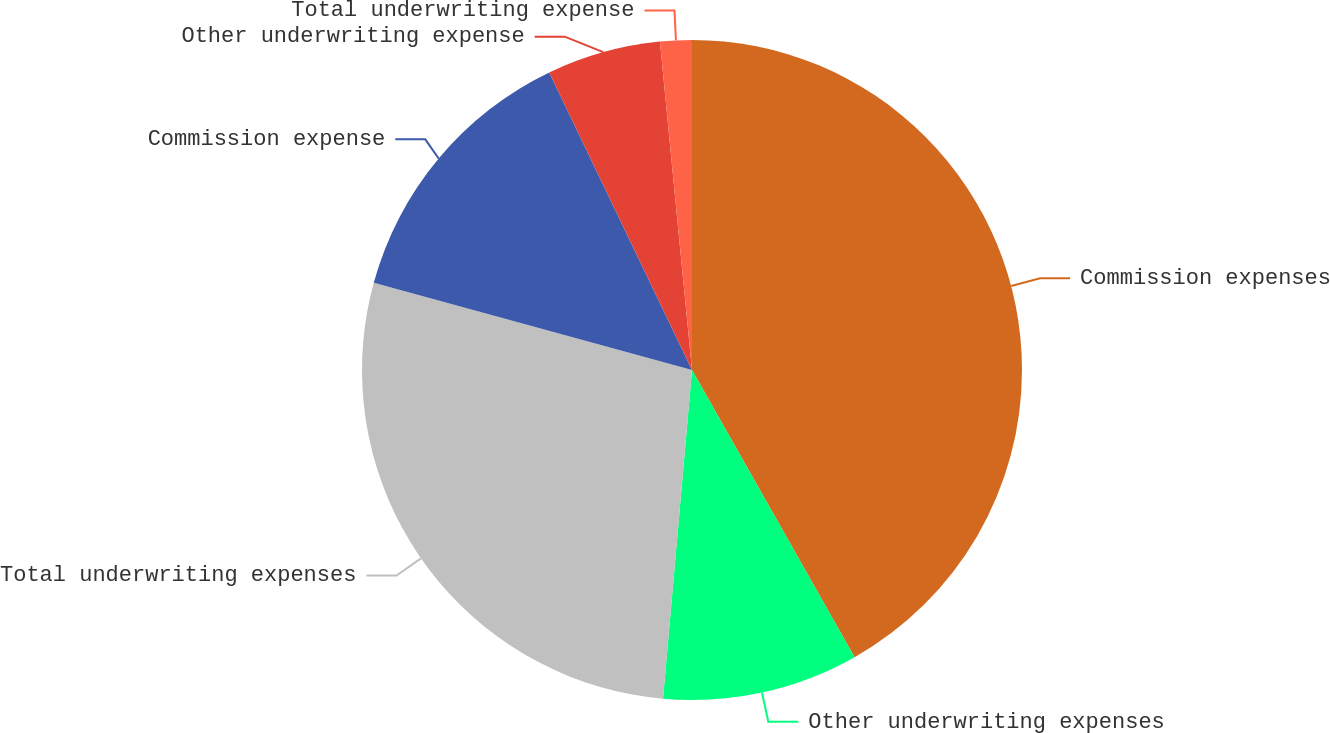Convert chart. <chart><loc_0><loc_0><loc_500><loc_500><pie_chart><fcel>Commission expenses<fcel>Other underwriting expenses<fcel>Total underwriting expenses<fcel>Commission expense<fcel>Other underwriting expense<fcel>Total underwriting expense<nl><fcel>41.8%<fcel>9.6%<fcel>27.86%<fcel>13.62%<fcel>5.57%<fcel>1.55%<nl></chart> 